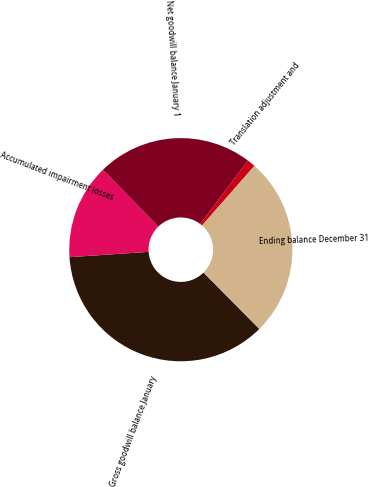Convert chart. <chart><loc_0><loc_0><loc_500><loc_500><pie_chart><fcel>Gross goodwill balance January<fcel>Accumulated impairment losses<fcel>Net goodwill balance January 1<fcel>Translation adjustment and<fcel>Ending balance December 31<nl><fcel>36.36%<fcel>13.78%<fcel>22.58%<fcel>1.18%<fcel>26.1%<nl></chart> 